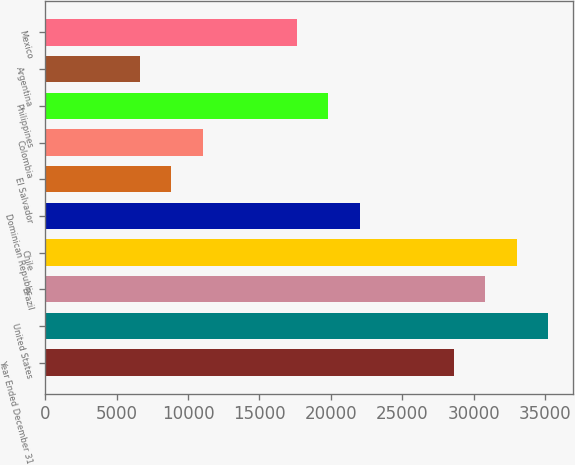<chart> <loc_0><loc_0><loc_500><loc_500><bar_chart><fcel>Year Ended December 31<fcel>United States<fcel>Brazil<fcel>Chile<fcel>Dominican Republic<fcel>El Salvador<fcel>Colombia<fcel>Philippines<fcel>Argentina<fcel>Mexico<nl><fcel>28623.5<fcel>35225<fcel>30824<fcel>33024.5<fcel>22022<fcel>8819<fcel>11019.5<fcel>19821.5<fcel>6618.5<fcel>17621<nl></chart> 